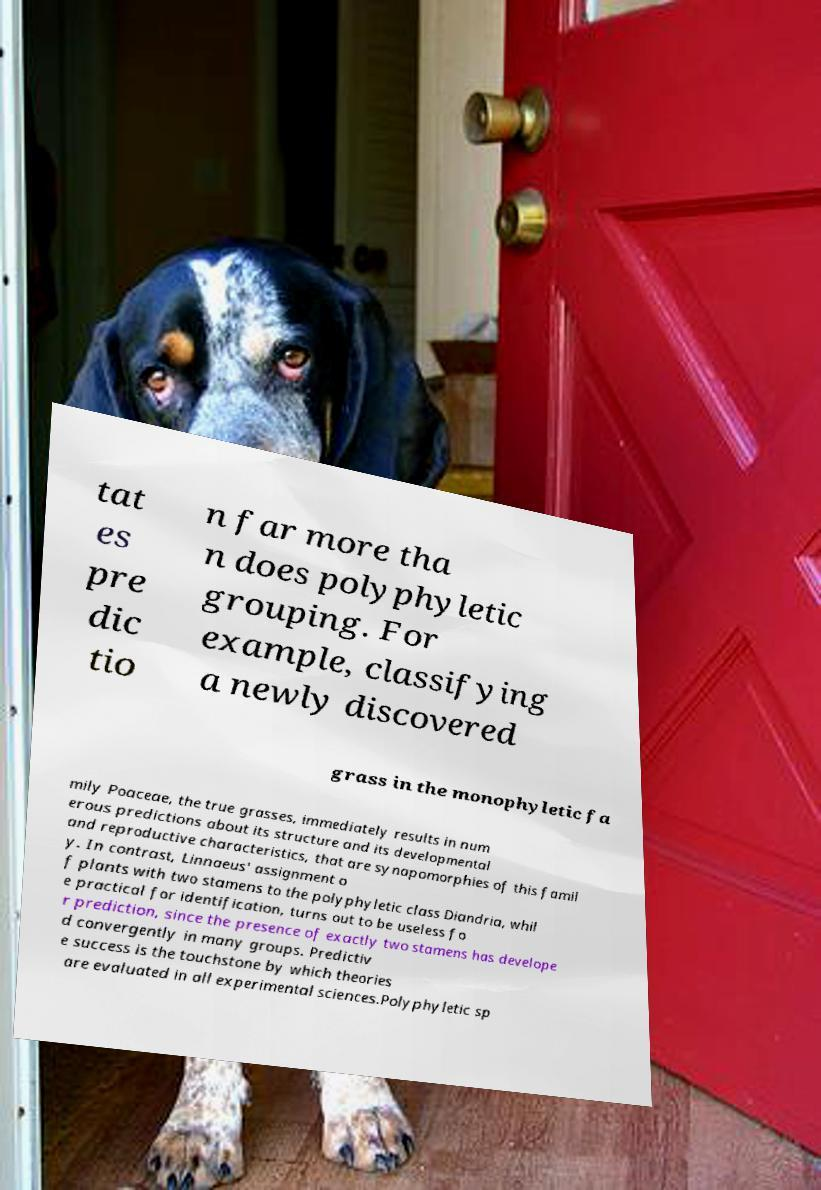Can you accurately transcribe the text from the provided image for me? tat es pre dic tio n far more tha n does polyphyletic grouping. For example, classifying a newly discovered grass in the monophyletic fa mily Poaceae, the true grasses, immediately results in num erous predictions about its structure and its developmental and reproductive characteristics, that are synapomorphies of this famil y. In contrast, Linnaeus' assignment o f plants with two stamens to the polyphyletic class Diandria, whil e practical for identification, turns out to be useless fo r prediction, since the presence of exactly two stamens has develope d convergently in many groups. Predictiv e success is the touchstone by which theories are evaluated in all experimental sciences.Polyphyletic sp 